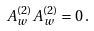<formula> <loc_0><loc_0><loc_500><loc_500>A _ { w } ^ { ( 2 ) } A _ { w } ^ { ( 2 ) } = 0 \, .</formula> 